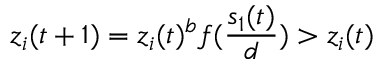Convert formula to latex. <formula><loc_0><loc_0><loc_500><loc_500>z _ { i } ( t + 1 ) = z _ { i } ( t ) ^ { b } f ( \frac { s _ { 1 } ( t ) } { d } ) > z _ { i } ( t )</formula> 